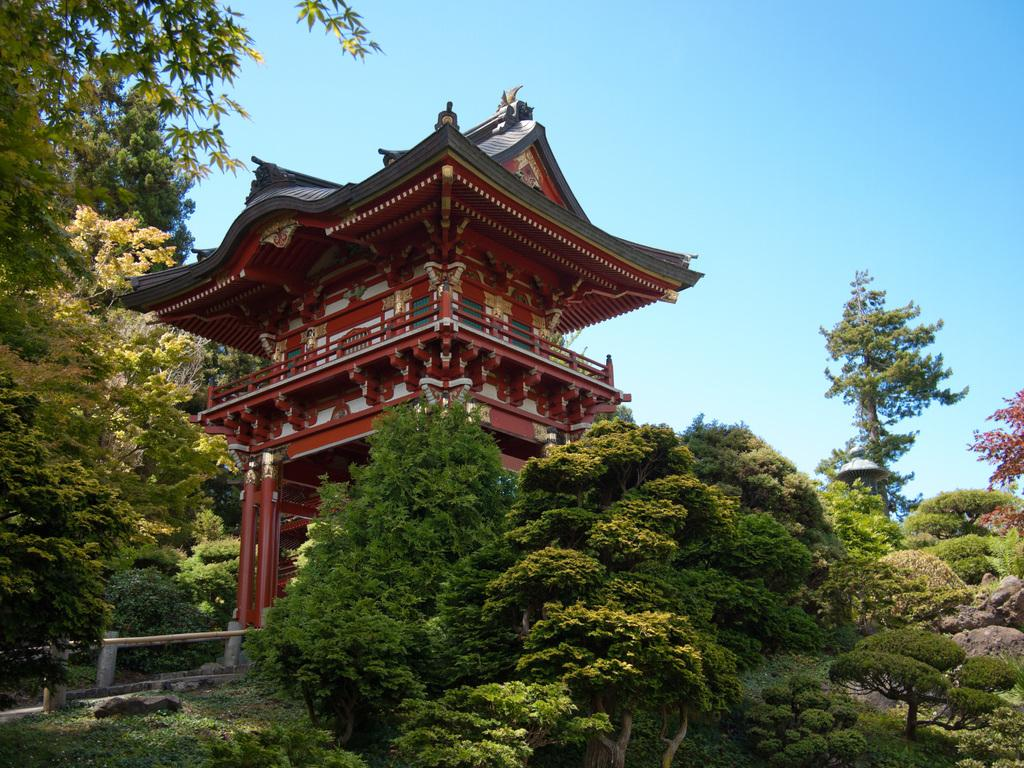What type of structure is present in the image? There is a building in the image. What surrounds the building? The building is surrounded by trees. What is the location of the trees in relation to the land? The trees are on land. What else can be found on the land? There are rocks on the land. What is visible at the top of the image? The sky is visible at the top of the image. What is located at the left bottom of the image? There is a fence at the left bottom of the image. What type of leaf is being used as a sack to carry the vessel in the image? There is no leaf, sack, or vessel present in the image. 